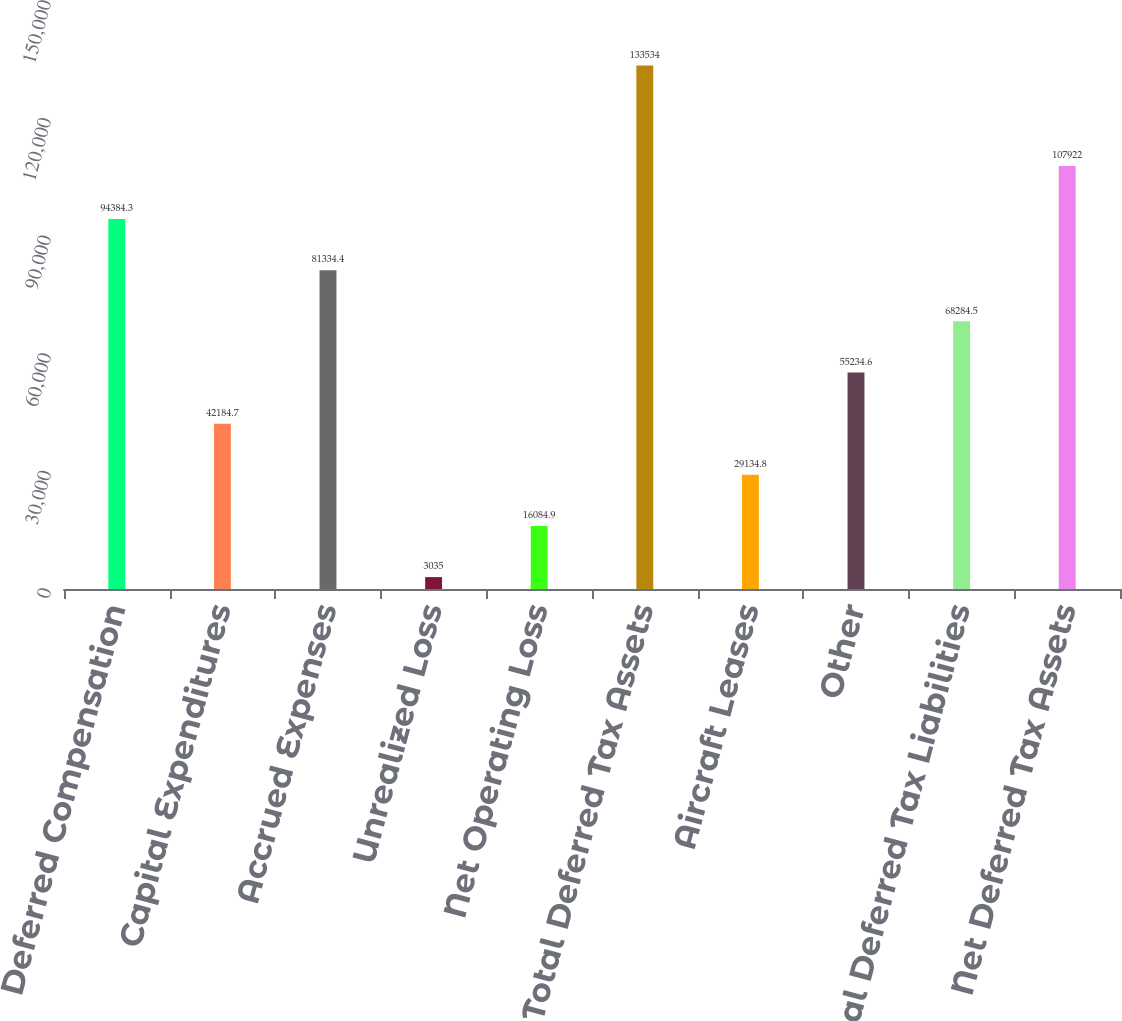<chart> <loc_0><loc_0><loc_500><loc_500><bar_chart><fcel>Deferred Compensation<fcel>Capital Expenditures<fcel>Accrued Expenses<fcel>Unrealized Loss<fcel>Net Operating Loss<fcel>Total Deferred Tax Assets<fcel>Aircraft Leases<fcel>Other<fcel>Total Deferred Tax Liabilities<fcel>Net Deferred Tax Assets<nl><fcel>94384.3<fcel>42184.7<fcel>81334.4<fcel>3035<fcel>16084.9<fcel>133534<fcel>29134.8<fcel>55234.6<fcel>68284.5<fcel>107922<nl></chart> 